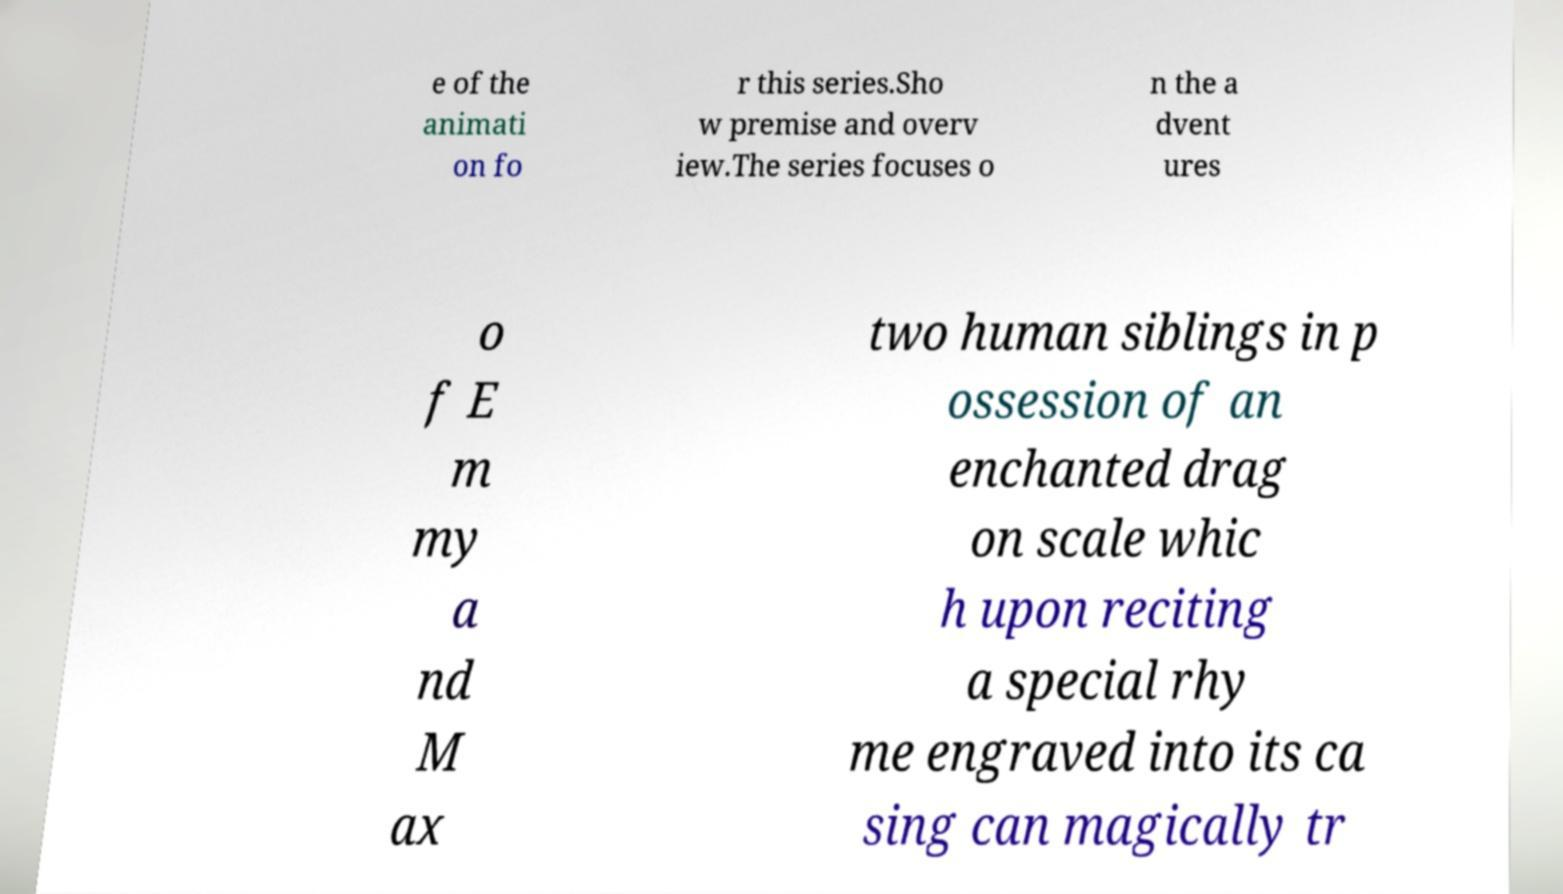Could you extract and type out the text from this image? e of the animati on fo r this series.Sho w premise and overv iew.The series focuses o n the a dvent ures o f E m my a nd M ax two human siblings in p ossession of an enchanted drag on scale whic h upon reciting a special rhy me engraved into its ca sing can magically tr 